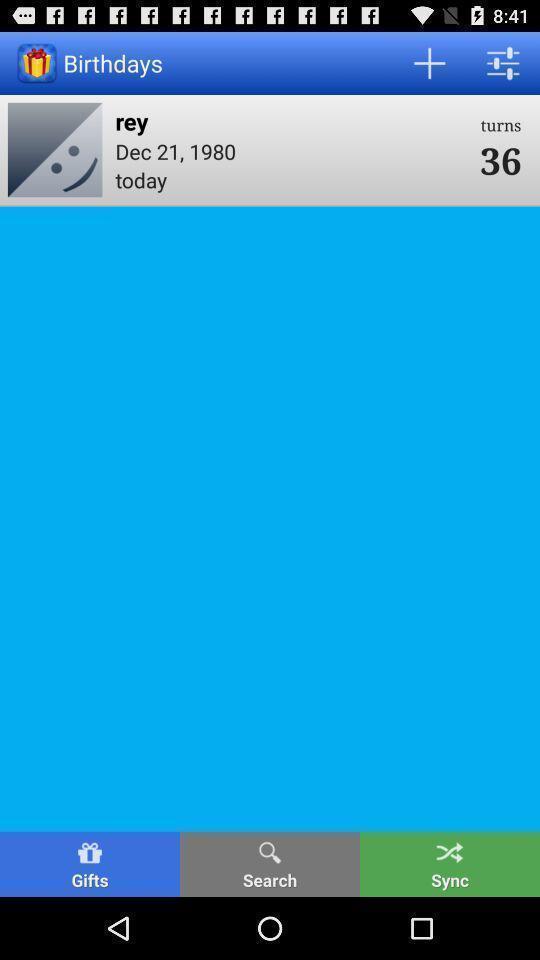What is the overall content of this screenshot? Page showing birthday reminder. 